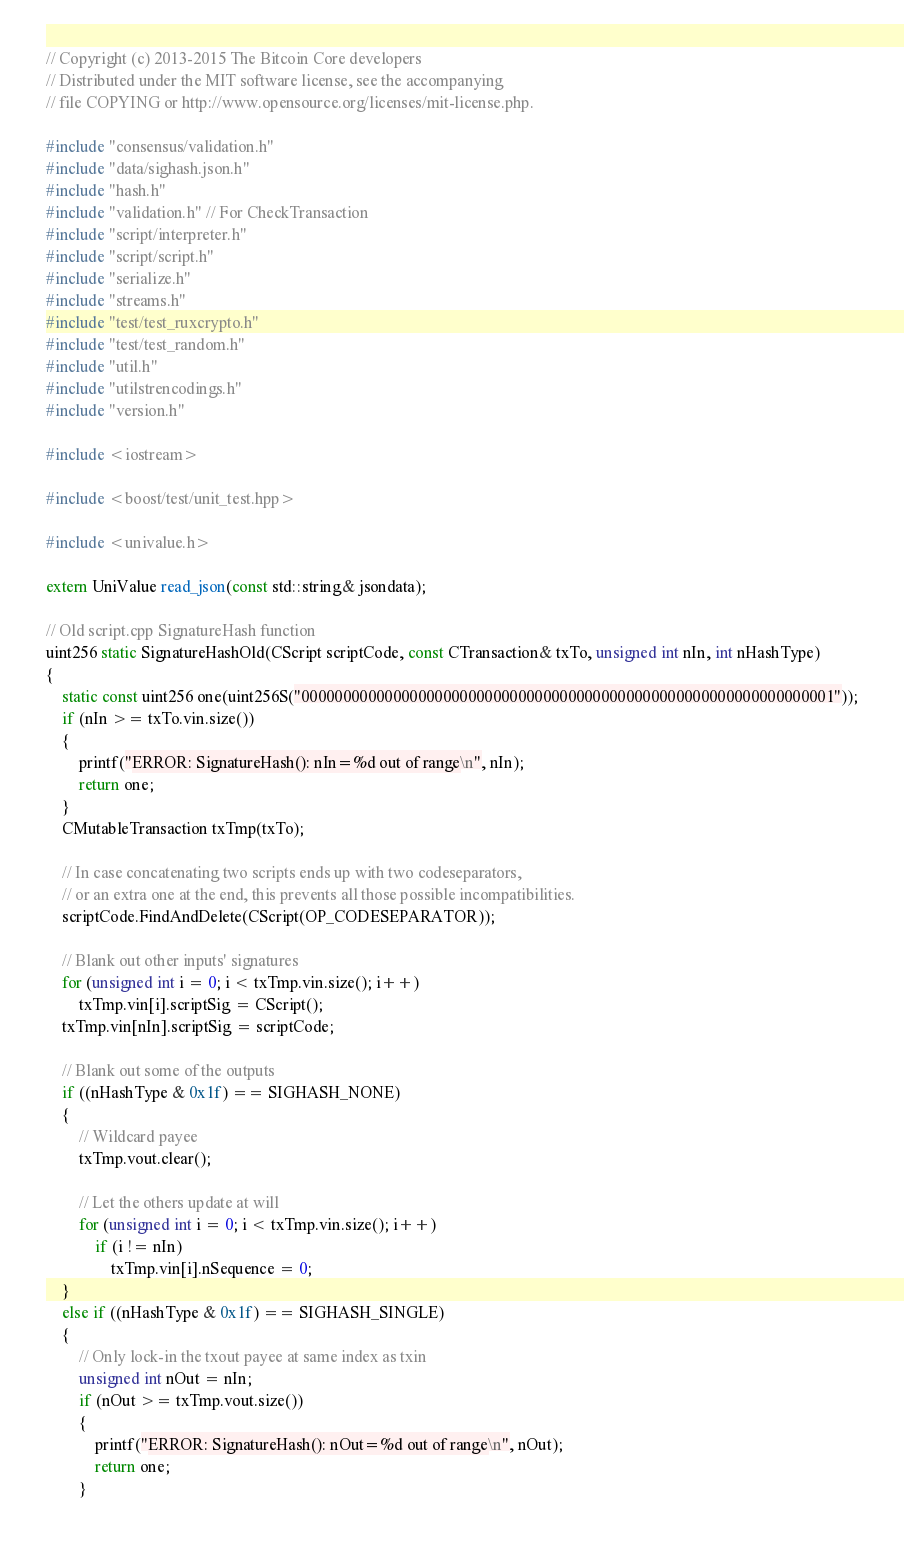Convert code to text. <code><loc_0><loc_0><loc_500><loc_500><_C++_>// Copyright (c) 2013-2015 The Bitcoin Core developers
// Distributed under the MIT software license, see the accompanying
// file COPYING or http://www.opensource.org/licenses/mit-license.php.

#include "consensus/validation.h"
#include "data/sighash.json.h"
#include "hash.h"
#include "validation.h" // For CheckTransaction
#include "script/interpreter.h"
#include "script/script.h"
#include "serialize.h"
#include "streams.h"
#include "test/test_ruxcrypto.h"
#include "test/test_random.h"
#include "util.h"
#include "utilstrencodings.h"
#include "version.h"

#include <iostream>

#include <boost/test/unit_test.hpp>

#include <univalue.h>

extern UniValue read_json(const std::string& jsondata);

// Old script.cpp SignatureHash function
uint256 static SignatureHashOld(CScript scriptCode, const CTransaction& txTo, unsigned int nIn, int nHashType)
{
    static const uint256 one(uint256S("0000000000000000000000000000000000000000000000000000000000000001"));
    if (nIn >= txTo.vin.size())
    {
        printf("ERROR: SignatureHash(): nIn=%d out of range\n", nIn);
        return one;
    }
    CMutableTransaction txTmp(txTo);

    // In case concatenating two scripts ends up with two codeseparators,
    // or an extra one at the end, this prevents all those possible incompatibilities.
    scriptCode.FindAndDelete(CScript(OP_CODESEPARATOR));

    // Blank out other inputs' signatures
    for (unsigned int i = 0; i < txTmp.vin.size(); i++)
        txTmp.vin[i].scriptSig = CScript();
    txTmp.vin[nIn].scriptSig = scriptCode;

    // Blank out some of the outputs
    if ((nHashType & 0x1f) == SIGHASH_NONE)
    {
        // Wildcard payee
        txTmp.vout.clear();

        // Let the others update at will
        for (unsigned int i = 0; i < txTmp.vin.size(); i++)
            if (i != nIn)
                txTmp.vin[i].nSequence = 0;
    }
    else if ((nHashType & 0x1f) == SIGHASH_SINGLE)
    {
        // Only lock-in the txout payee at same index as txin
        unsigned int nOut = nIn;
        if (nOut >= txTmp.vout.size())
        {
            printf("ERROR: SignatureHash(): nOut=%d out of range\n", nOut);
            return one;
        }</code> 